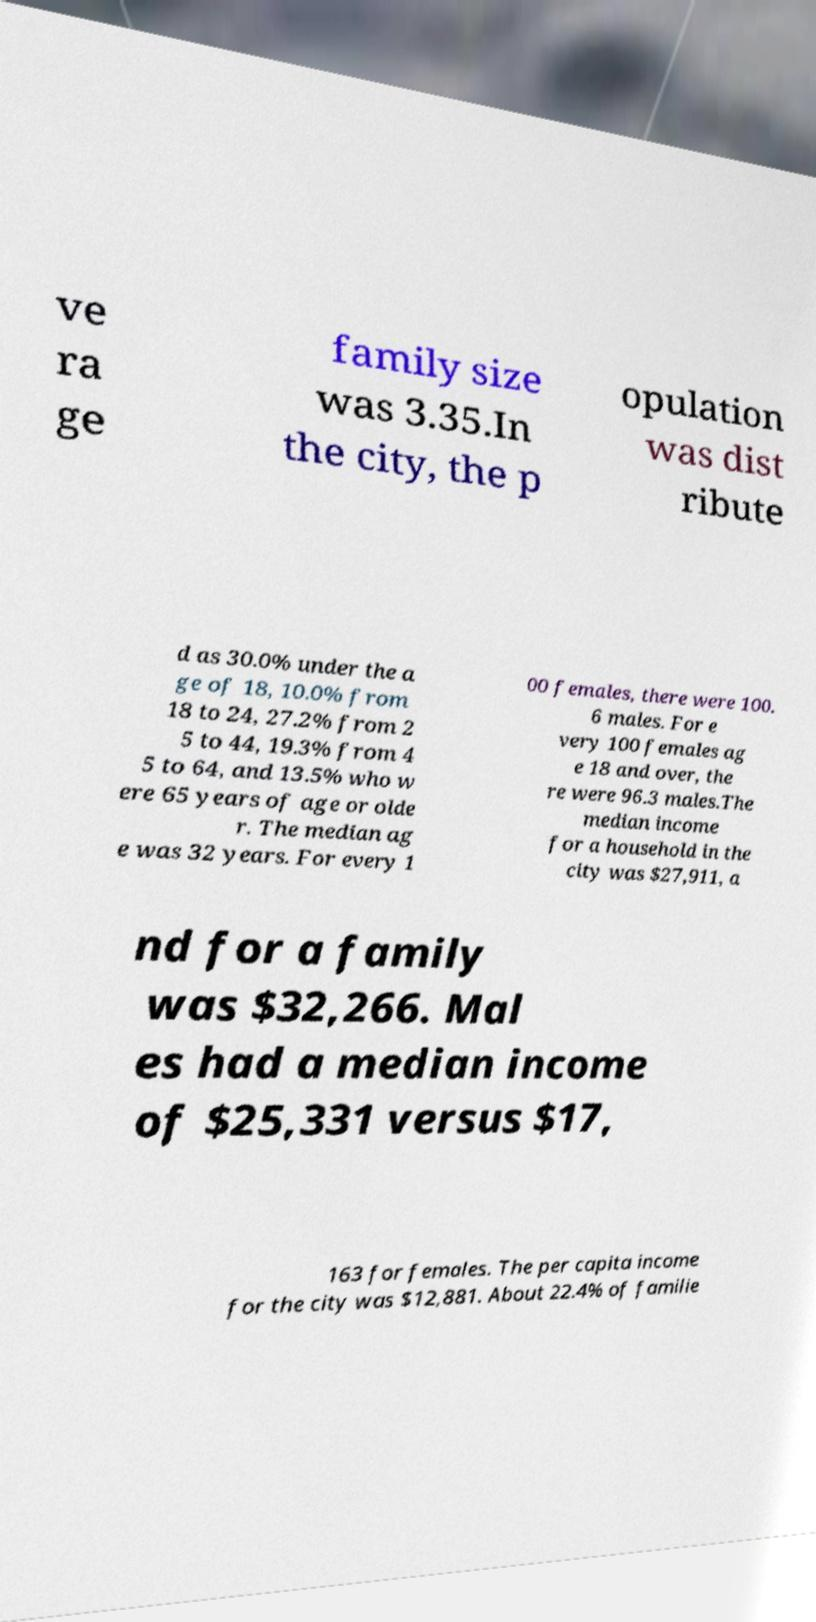Could you extract and type out the text from this image? ve ra ge family size was 3.35.In the city, the p opulation was dist ribute d as 30.0% under the a ge of 18, 10.0% from 18 to 24, 27.2% from 2 5 to 44, 19.3% from 4 5 to 64, and 13.5% who w ere 65 years of age or olde r. The median ag e was 32 years. For every 1 00 females, there were 100. 6 males. For e very 100 females ag e 18 and over, the re were 96.3 males.The median income for a household in the city was $27,911, a nd for a family was $32,266. Mal es had a median income of $25,331 versus $17, 163 for females. The per capita income for the city was $12,881. About 22.4% of familie 